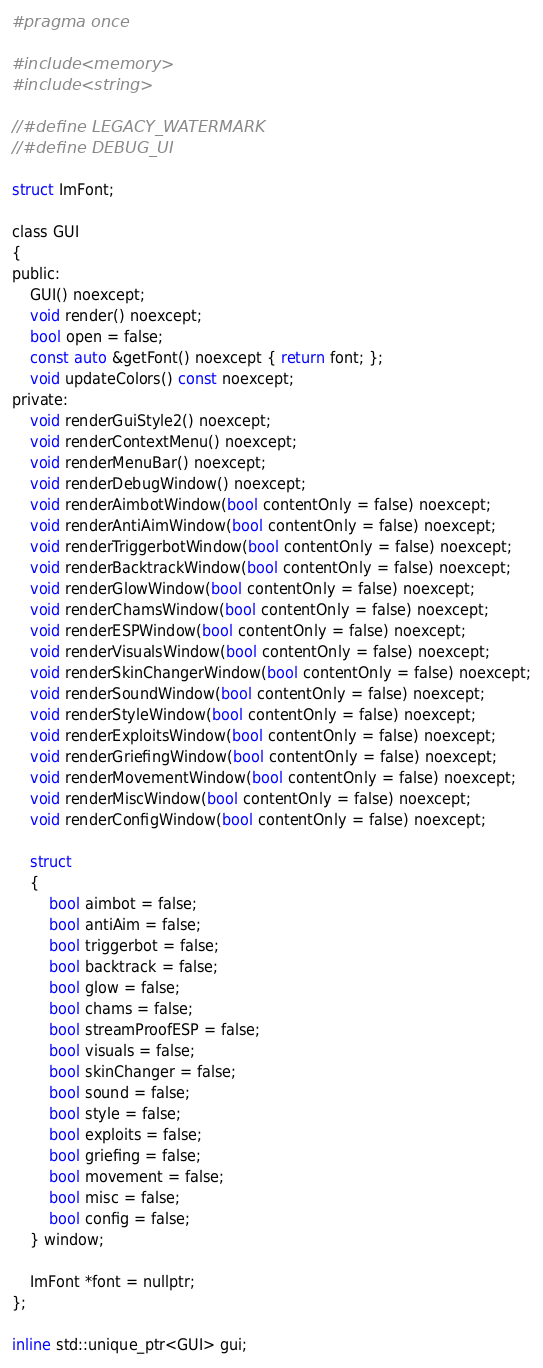Convert code to text. <code><loc_0><loc_0><loc_500><loc_500><_C_>#pragma once

#include <memory>
#include <string>

//#define LEGACY_WATERMARK
//#define DEBUG_UI

struct ImFont;

class GUI
{
public:
	GUI() noexcept;
	void render() noexcept;
	bool open = false;
	const auto &getFont() noexcept { return font; };
	void updateColors() const noexcept;
private:
	void renderGuiStyle2() noexcept;
	void renderContextMenu() noexcept;
	void renderMenuBar() noexcept;
	void renderDebugWindow() noexcept;
	void renderAimbotWindow(bool contentOnly = false) noexcept;
	void renderAntiAimWindow(bool contentOnly = false) noexcept;
	void renderTriggerbotWindow(bool contentOnly = false) noexcept;
	void renderBacktrackWindow(bool contentOnly = false) noexcept;
	void renderGlowWindow(bool contentOnly = false) noexcept;
	void renderChamsWindow(bool contentOnly = false) noexcept;
	void renderESPWindow(bool contentOnly = false) noexcept;
	void renderVisualsWindow(bool contentOnly = false) noexcept;
	void renderSkinChangerWindow(bool contentOnly = false) noexcept;
	void renderSoundWindow(bool contentOnly = false) noexcept;
	void renderStyleWindow(bool contentOnly = false) noexcept;
	void renderExploitsWindow(bool contentOnly = false) noexcept;
	void renderGriefingWindow(bool contentOnly = false) noexcept;
	void renderMovementWindow(bool contentOnly = false) noexcept;
	void renderMiscWindow(bool contentOnly = false) noexcept;
	void renderConfigWindow(bool contentOnly = false) noexcept;

	struct
	{
		bool aimbot = false;
		bool antiAim = false;
		bool triggerbot = false;
		bool backtrack = false;
		bool glow = false;
		bool chams = false;
		bool streamProofESP = false;
		bool visuals = false;
		bool skinChanger = false;
		bool sound = false;
		bool style = false;
		bool exploits = false;
		bool griefing = false;
		bool movement = false;
		bool misc = false;
		bool config = false;
	} window;

	ImFont *font = nullptr;
};

inline std::unique_ptr<GUI> gui;
</code> 